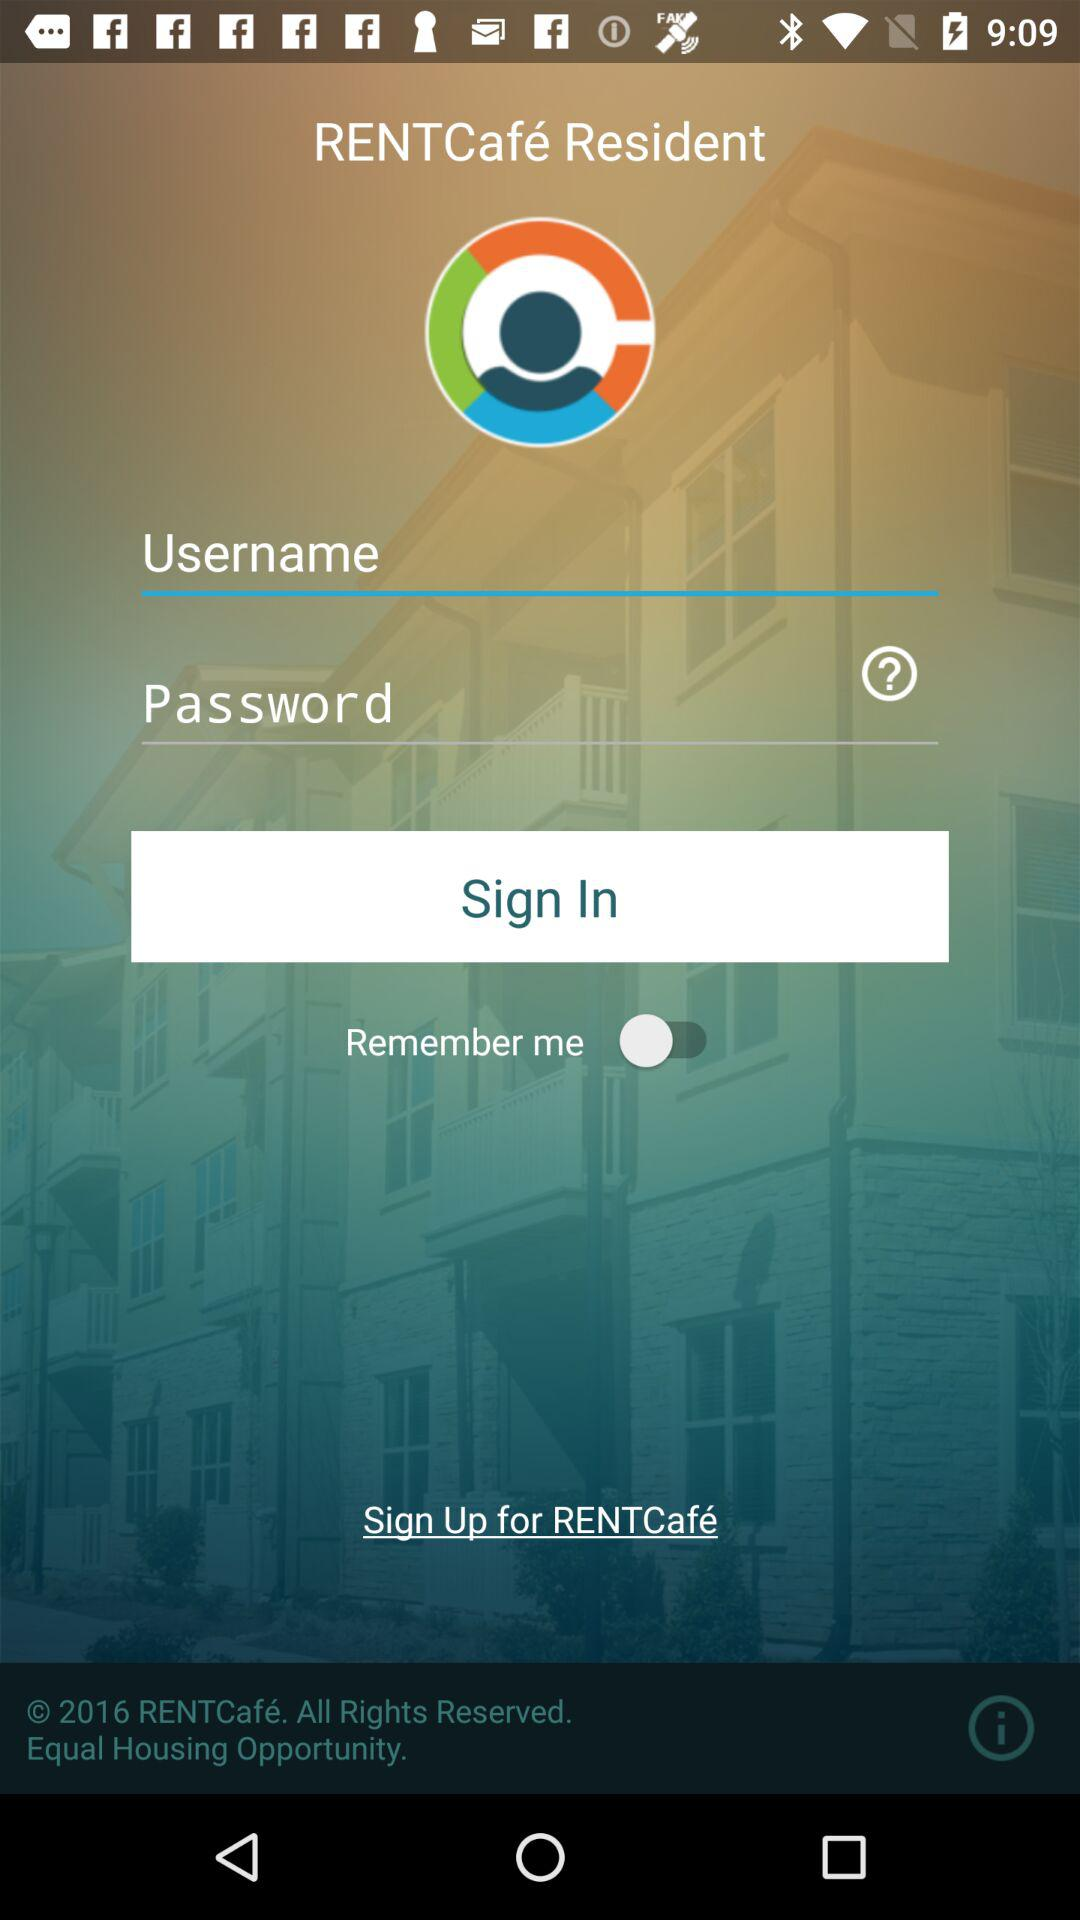How many characters are required to create a password?
When the provided information is insufficient, respond with <no answer>. <no answer> 